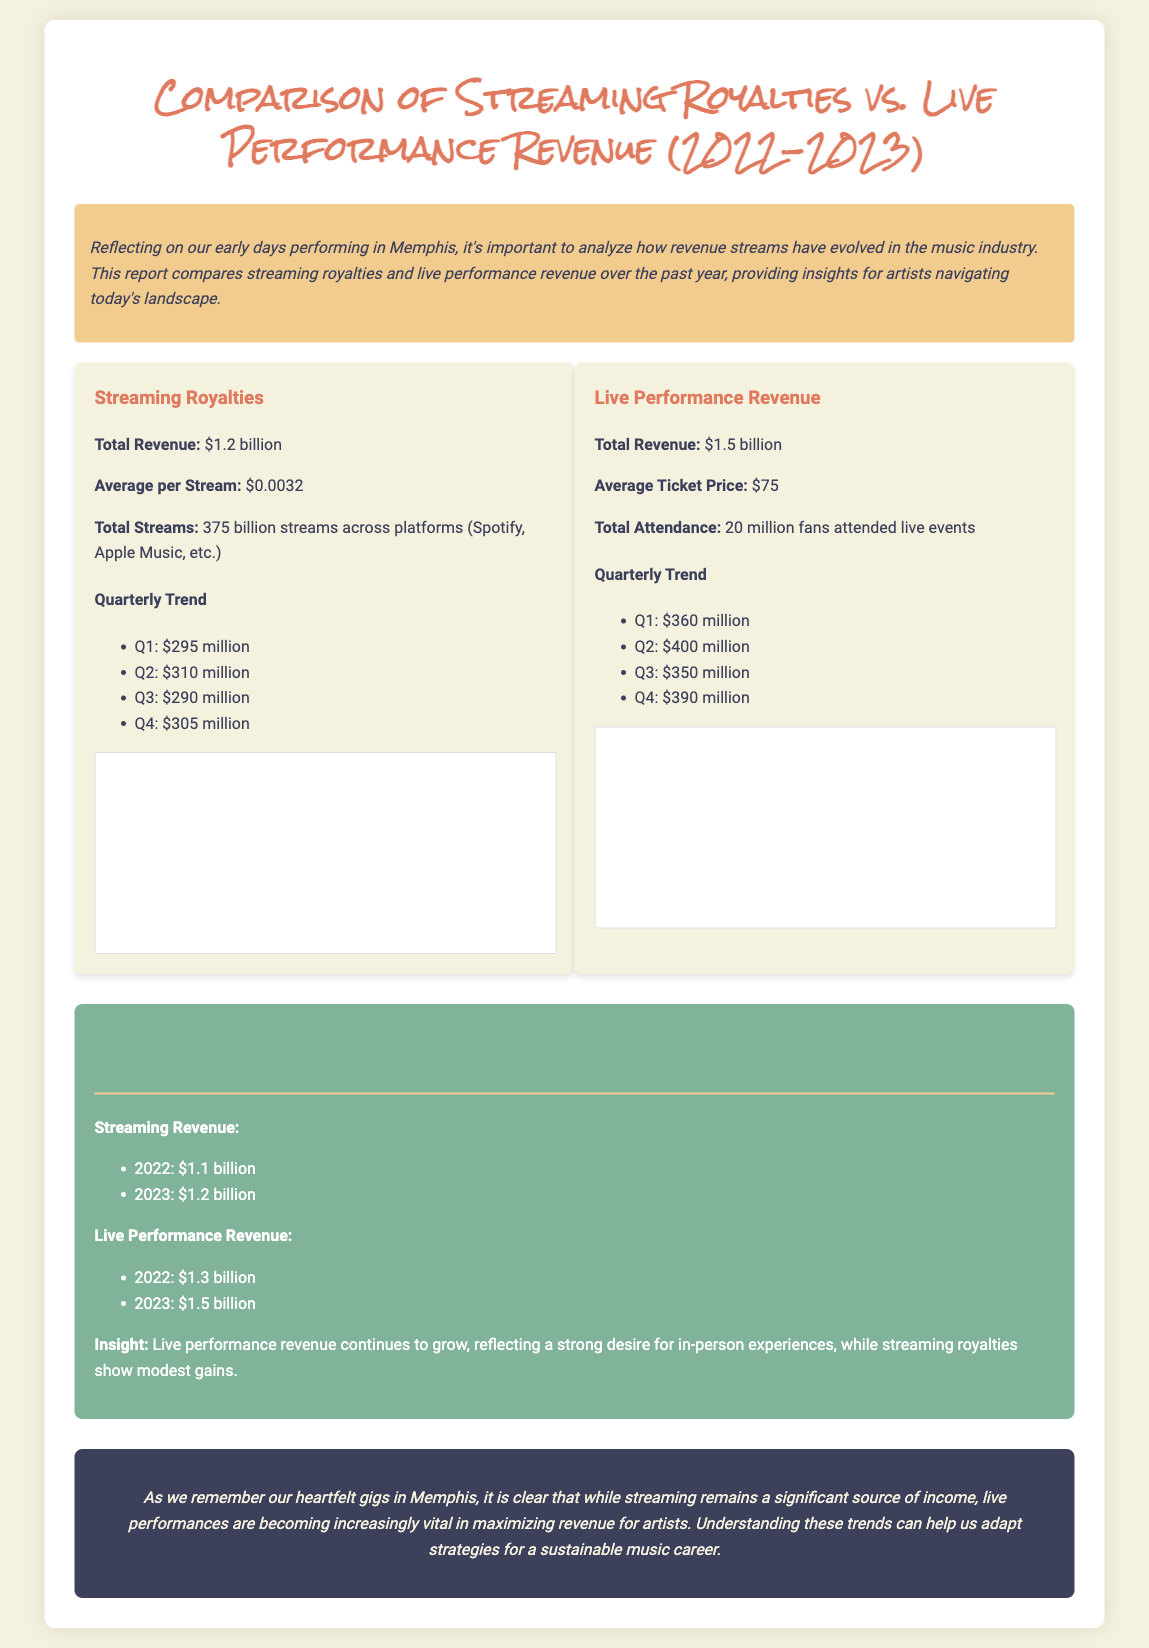what is the total revenue for streaming royalties? The total revenue for streaming royalties is listed as $1.2 billion.
Answer: $1.2 billion what is the total revenue for live performance? The total revenue for live performance is provided as $1.5 billion.
Answer: $1.5 billion what was the average ticket price for live performances? The average ticket price for live performances is stated as $75.
Answer: $75 which quarter had the highest streaming revenue? The quarter with the highest streaming revenue is Q2 with $310 million.
Answer: Q2 how many total streams were recorded across platforms? The document states that there were 375 billion streams across platforms.
Answer: 375 billion streams what was the quarterly revenue for live performances in Q3? The quarterly revenue for live performances in Q3 is given as $350 million.
Answer: $350 million which revenue source had a higher total in 2023? The higher total revenue source in 2023 is live performance revenue.
Answer: live performance revenue what is the insight shared regarding revenue trends? The insight indicates that live performance revenue continues to grow, reflecting a desire for in-person experiences.
Answer: Live performance revenue continues to grow 